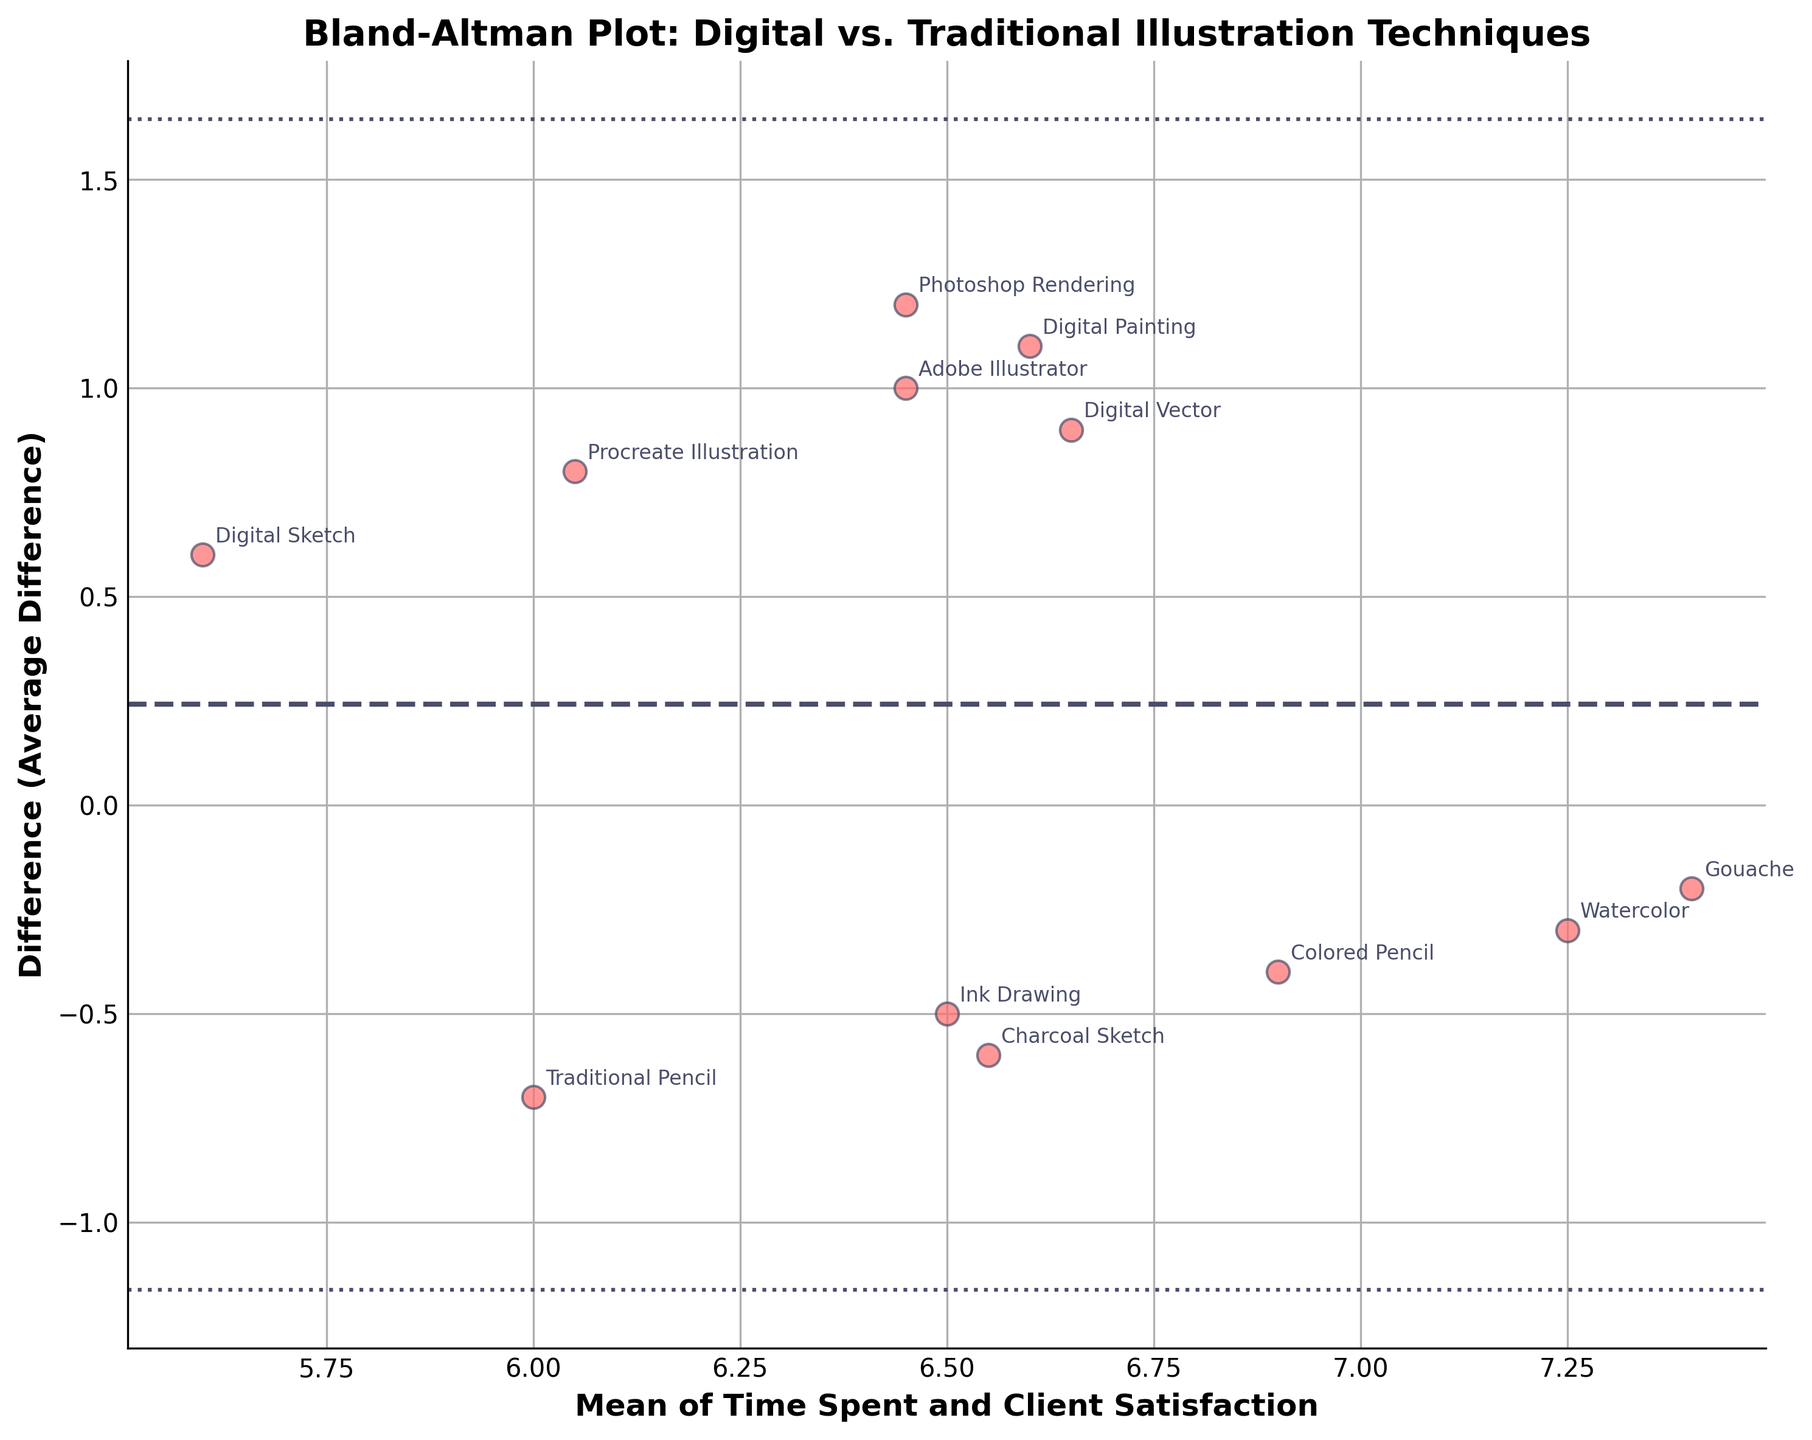What is the title of the plot? The title is displayed at the top of the plot and summarizes what the plot is about.
Answer: Bland-Altman Plot: Digital vs. Traditional Illustration Techniques How many data points are shown in the plot? Count the number of unique scatter points shown in the plot.
Answer: 12 What do the horizontal dashed and dotted lines represent? The dashed line is the mean difference, while the dotted lines represent the limits of agreement (mean difference ± 1.96 times the standard deviation of the differences).
Answer: Mean difference and limits of agreement Which technique has the largest positive average difference? Identify the data point with the largest positive difference on the vertical axis.
Answer: Photoshop Rendering What is the mean of the "Digital Sketch" time spent and client satisfaction? Find the mean of the time spent (2.5) and client satisfaction (8.7) for the "Digital Sketch".
Answer: 5.6 Are there more techniques with a positive or a negative average difference? Count the number of points above and below the 0 difference line.
Answer: Positive What is the approximate mean difference value shown by the dashed line? Observe the horizontal position of the dashed line on the y-axis.
Answer: 0.4 Which traditional technique has the highest client satisfaction? Identify the traditional technique with the highest value on the client satisfaction dimension.
Answer: Watercolor Which digital technique has the smallest time spent? Identify the digital technique with the smallest value on the time spent dimension.
Answer: Digital Sketch Do digital techniques generally show higher client satisfaction than traditional techniques? Compare the client satisfaction values for digital versus traditional techniques.
Answer: Yes 